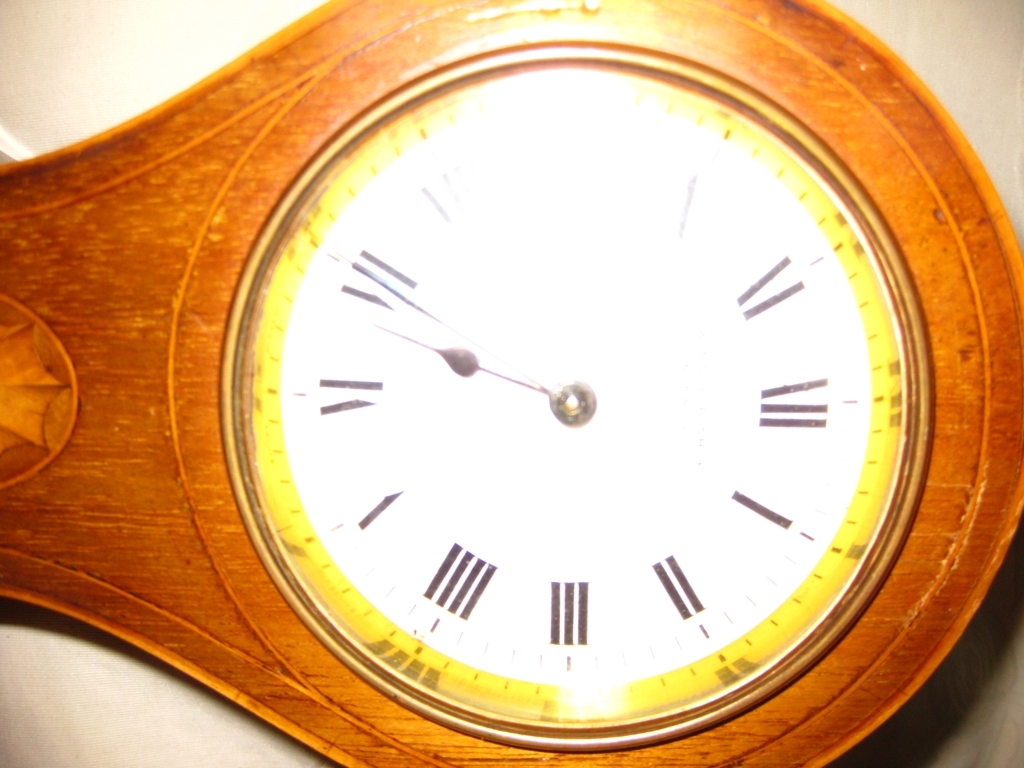Can you describe the style or era this clock might be from? The clock, with its classic round face and Roman numeral indicators, suggests a traditional design that might be seen in timepieces from the 20th century or earlier. The wooden casing with its carved detailing gives it an antique aesthetic, hinting that it could be a vintage item cherished for its craftsmanship. 